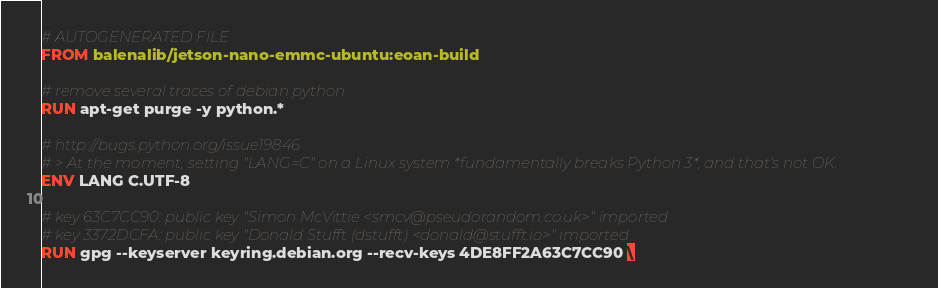<code> <loc_0><loc_0><loc_500><loc_500><_Dockerfile_># AUTOGENERATED FILE
FROM balenalib/jetson-nano-emmc-ubuntu:eoan-build

# remove several traces of debian python
RUN apt-get purge -y python.*

# http://bugs.python.org/issue19846
# > At the moment, setting "LANG=C" on a Linux system *fundamentally breaks Python 3*, and that's not OK.
ENV LANG C.UTF-8

# key 63C7CC90: public key "Simon McVittie <smcv@pseudorandom.co.uk>" imported
# key 3372DCFA: public key "Donald Stufft (dstufft) <donald@stufft.io>" imported
RUN gpg --keyserver keyring.debian.org --recv-keys 4DE8FF2A63C7CC90 \</code> 